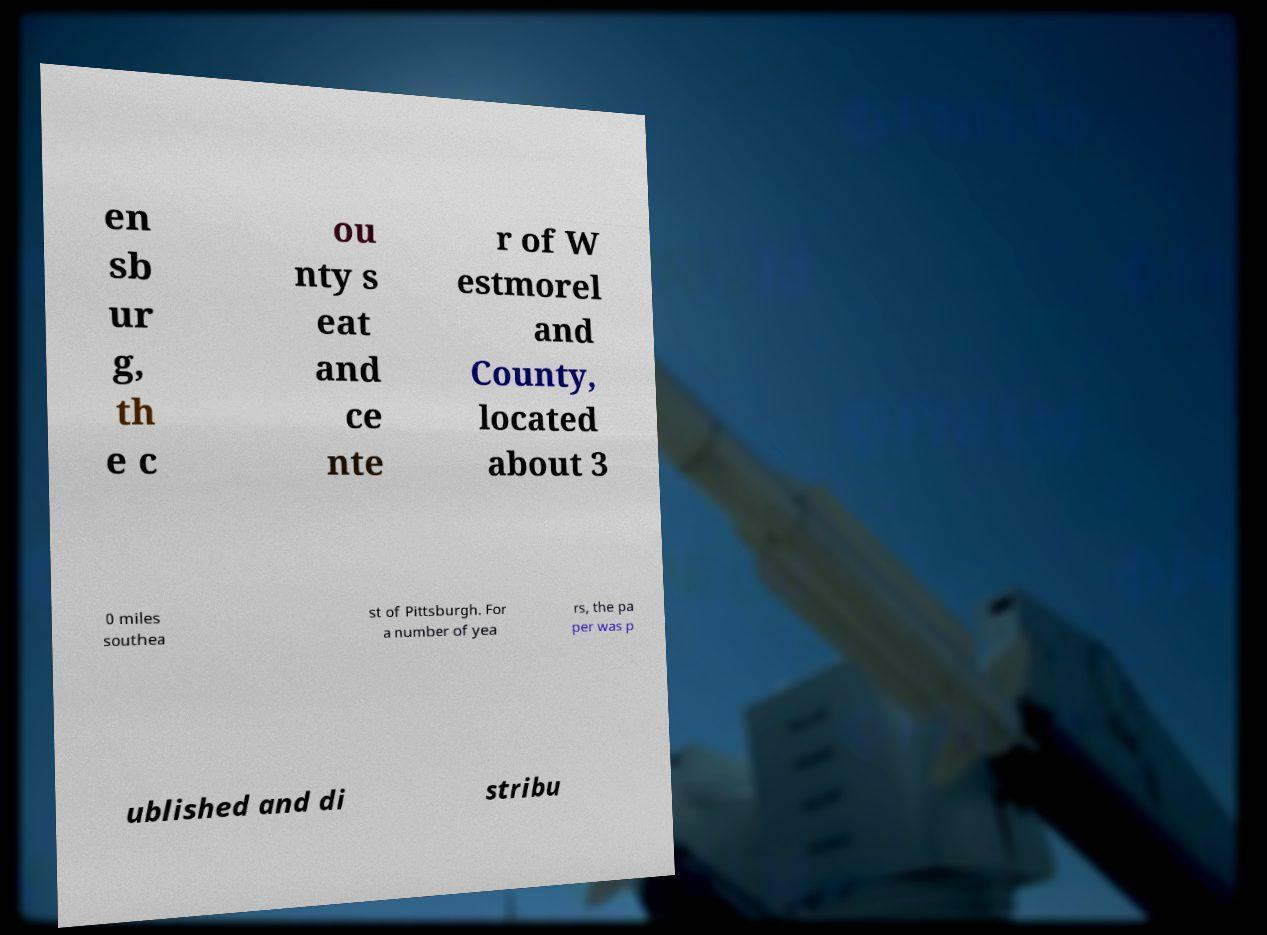For documentation purposes, I need the text within this image transcribed. Could you provide that? en sb ur g, th e c ou nty s eat and ce nte r of W estmorel and County, located about 3 0 miles southea st of Pittsburgh. For a number of yea rs, the pa per was p ublished and di stribu 